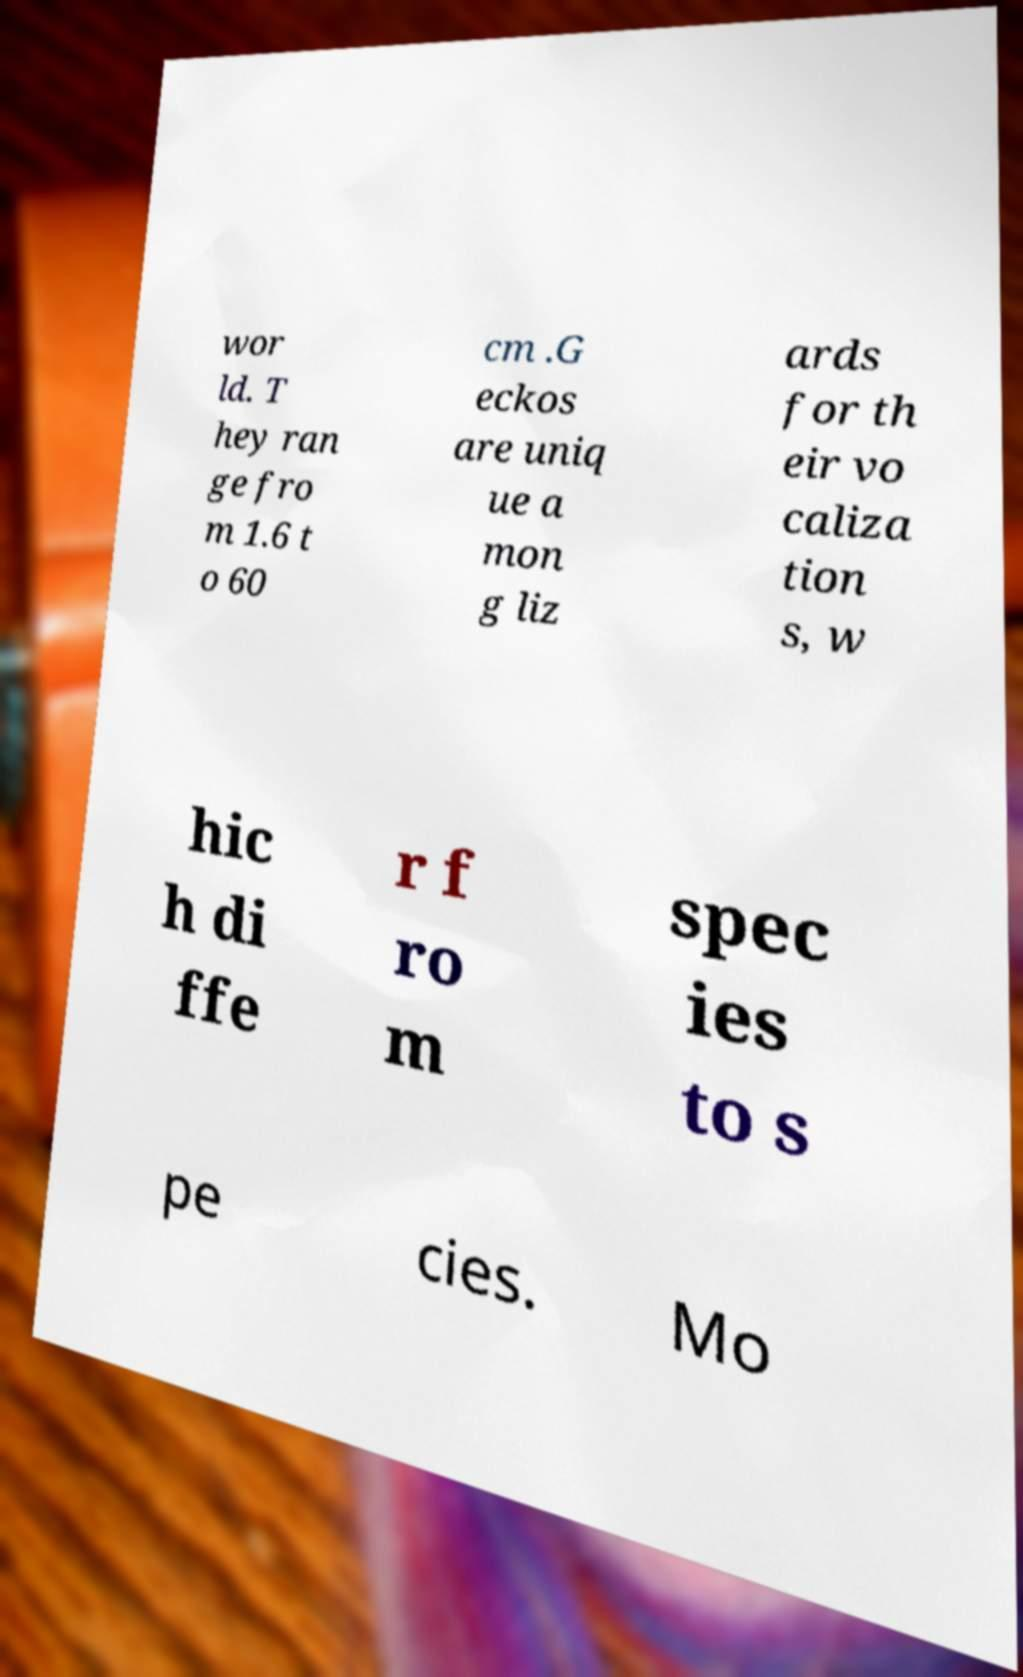What messages or text are displayed in this image? I need them in a readable, typed format. wor ld. T hey ran ge fro m 1.6 t o 60 cm .G eckos are uniq ue a mon g liz ards for th eir vo caliza tion s, w hic h di ffe r f ro m spec ies to s pe cies. Mo 